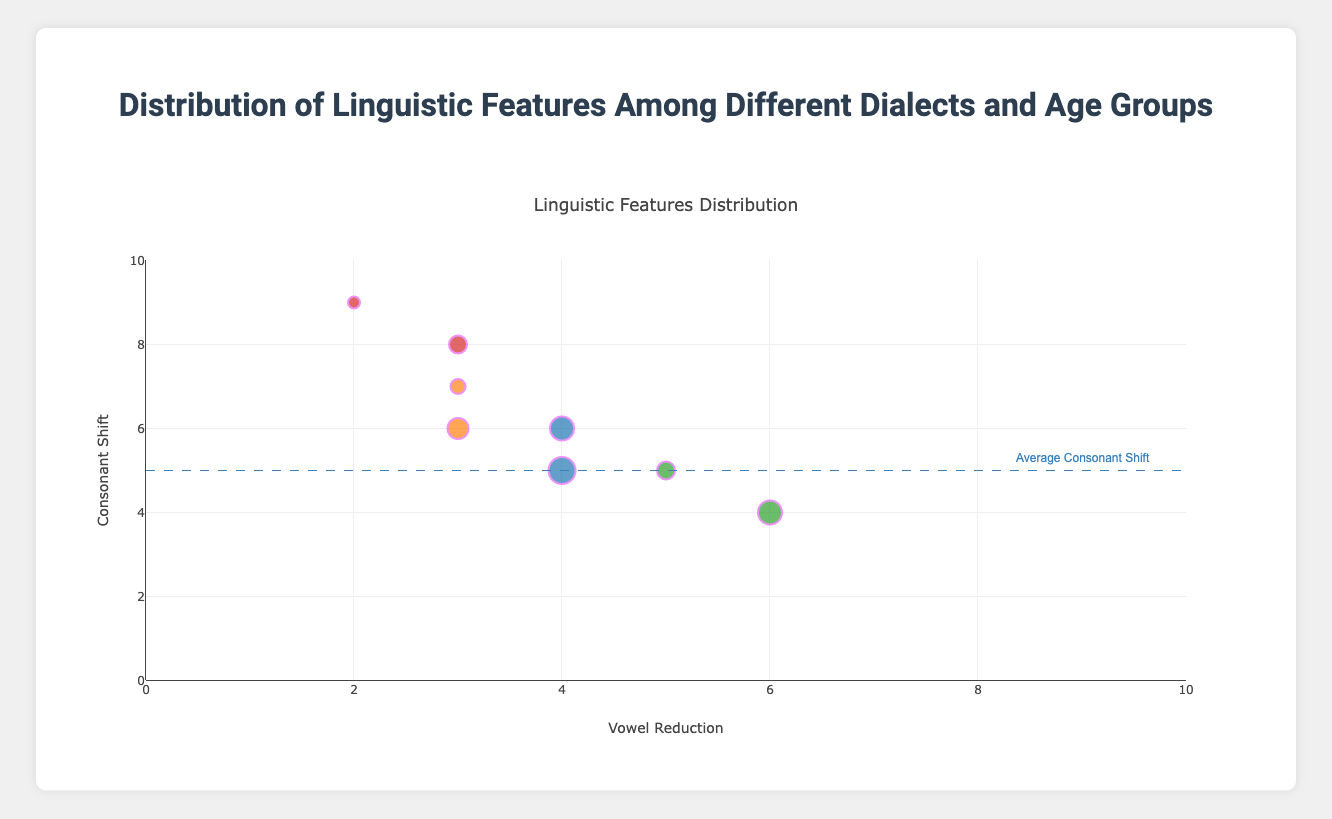What's the title of the figure? The title is located at the top center of the figure. It provides a summary of what the plot represents.
Answer: Distribution of Linguistic Features Among Different Dialects and Age Groups What do the x and y axes represent? The x-axis is labeled "Vowel Reduction" and the y-axis is labeled "Consonant Shift." These labels indicate the phonetic features being measured.
Answer: Vowel Reduction and Consonant Shift Which dialect is represented by the color orange in the plot? By looking at the legend or the trace information, we can see that the color orange is used for the Southern dialect.
Answer: Southern What linguistic feature is represented by the size of the markers? The marker size represents the "Aspiration" feature, which scales with its value. Larger markers indicate higher aspiration values.
Answer: Aspiration Is there a trend in consonant shift values based on age groups? Each data point is annotated with age group information. Observing the y-axis position of the points with various age groups helps determine any trend. There is no strong visible trend only based on the visual data given.
Answer: No clear trend Which age group in the Southern dialect has the highest consonant shift? By identifying the points color-coded for Southern dialect and checking their y-axis positions, the "18-25" age group marker has the highest consonant shift value of 7.
Answer: 18-25 Comparing 'Northern' and 'Western' dialects, which one has a higher average vowel reduction? First, identify data points for each dialect and note their vowel reduction values. Calculate the average for each. Northern: (4 + 4) / 2 = 4, Western: (2 + 3) / 2 = 2.5. Northern has a higher average.
Answer: Northern How many total markers represent the '18-25' age group? Identify the markers annotated with the "18-25" age group. There are three such points in the figure.
Answer: 3 What does the dashed horizontal line at y=5 represent? Along the y-axis, a dashed line marks the average consonant shift value, which is accompanied by an annotation "Average Consonant Shift."
Answer: Average Consonant Shift How is the information about gender conveyed in the plot? Gender is included in the annotation text of each marker, showing "Female" or "Male" alongside age group and dialect.
Answer: Annotations 